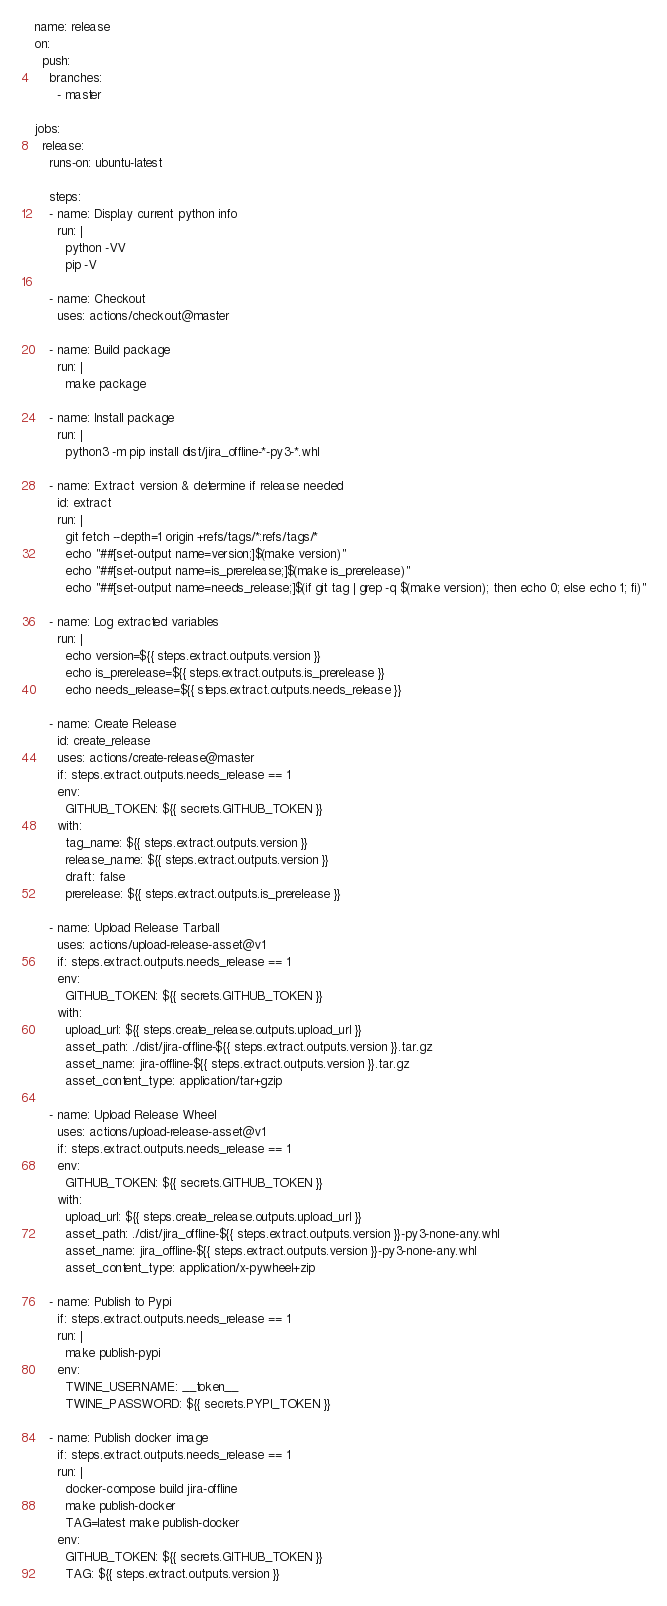<code> <loc_0><loc_0><loc_500><loc_500><_YAML_>name: release
on:
  push:
    branches:
      - master

jobs:
  release:
    runs-on: ubuntu-latest

    steps:
    - name: Display current python info
      run: |
        python -VV
        pip -V

    - name: Checkout
      uses: actions/checkout@master

    - name: Build package
      run: |
        make package

    - name: Install package
      run: |
        python3 -m pip install dist/jira_offline-*-py3-*.whl

    - name: Extract version & determine if release needed
      id: extract
      run: |
        git fetch --depth=1 origin +refs/tags/*:refs/tags/*
        echo "##[set-output name=version;]$(make version)"
        echo "##[set-output name=is_prerelease;]$(make is_prerelease)"
        echo "##[set-output name=needs_release;]$(if git tag | grep -q $(make version); then echo 0; else echo 1; fi)"

    - name: Log extracted variables
      run: |
        echo version=${{ steps.extract.outputs.version }}
        echo is_prerelease=${{ steps.extract.outputs.is_prerelease }}
        echo needs_release=${{ steps.extract.outputs.needs_release }}

    - name: Create Release
      id: create_release
      uses: actions/create-release@master
      if: steps.extract.outputs.needs_release == 1
      env:
        GITHUB_TOKEN: ${{ secrets.GITHUB_TOKEN }}
      with:
        tag_name: ${{ steps.extract.outputs.version }}
        release_name: ${{ steps.extract.outputs.version }}
        draft: false
        prerelease: ${{ steps.extract.outputs.is_prerelease }}

    - name: Upload Release Tarball
      uses: actions/upload-release-asset@v1
      if: steps.extract.outputs.needs_release == 1
      env:
        GITHUB_TOKEN: ${{ secrets.GITHUB_TOKEN }}
      with:
        upload_url: ${{ steps.create_release.outputs.upload_url }}
        asset_path: ./dist/jira-offline-${{ steps.extract.outputs.version }}.tar.gz
        asset_name: jira-offline-${{ steps.extract.outputs.version }}.tar.gz
        asset_content_type: application/tar+gzip

    - name: Upload Release Wheel
      uses: actions/upload-release-asset@v1
      if: steps.extract.outputs.needs_release == 1
      env:
        GITHUB_TOKEN: ${{ secrets.GITHUB_TOKEN }}
      with:
        upload_url: ${{ steps.create_release.outputs.upload_url }}
        asset_path: ./dist/jira_offline-${{ steps.extract.outputs.version }}-py3-none-any.whl
        asset_name: jira_offline-${{ steps.extract.outputs.version }}-py3-none-any.whl
        asset_content_type: application/x-pywheel+zip

    - name: Publish to Pypi
      if: steps.extract.outputs.needs_release == 1
      run: |
        make publish-pypi
      env:
        TWINE_USERNAME: __token__
        TWINE_PASSWORD: ${{ secrets.PYPI_TOKEN }}

    - name: Publish docker image
      if: steps.extract.outputs.needs_release == 1
      run: |
        docker-compose build jira-offline
        make publish-docker
        TAG=latest make publish-docker
      env:
        GITHUB_TOKEN: ${{ secrets.GITHUB_TOKEN }}
        TAG: ${{ steps.extract.outputs.version }}
</code> 